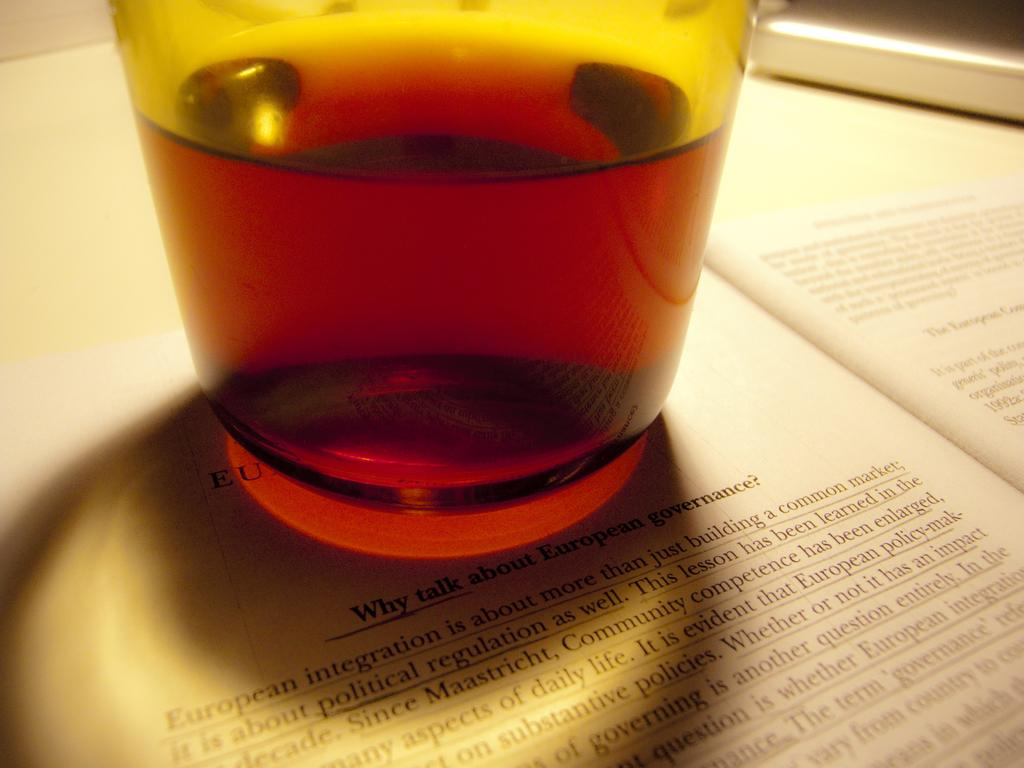Provide a one-sentence caption for the provided image. A drink sits on a book page over the header "why talk about European governance?". 